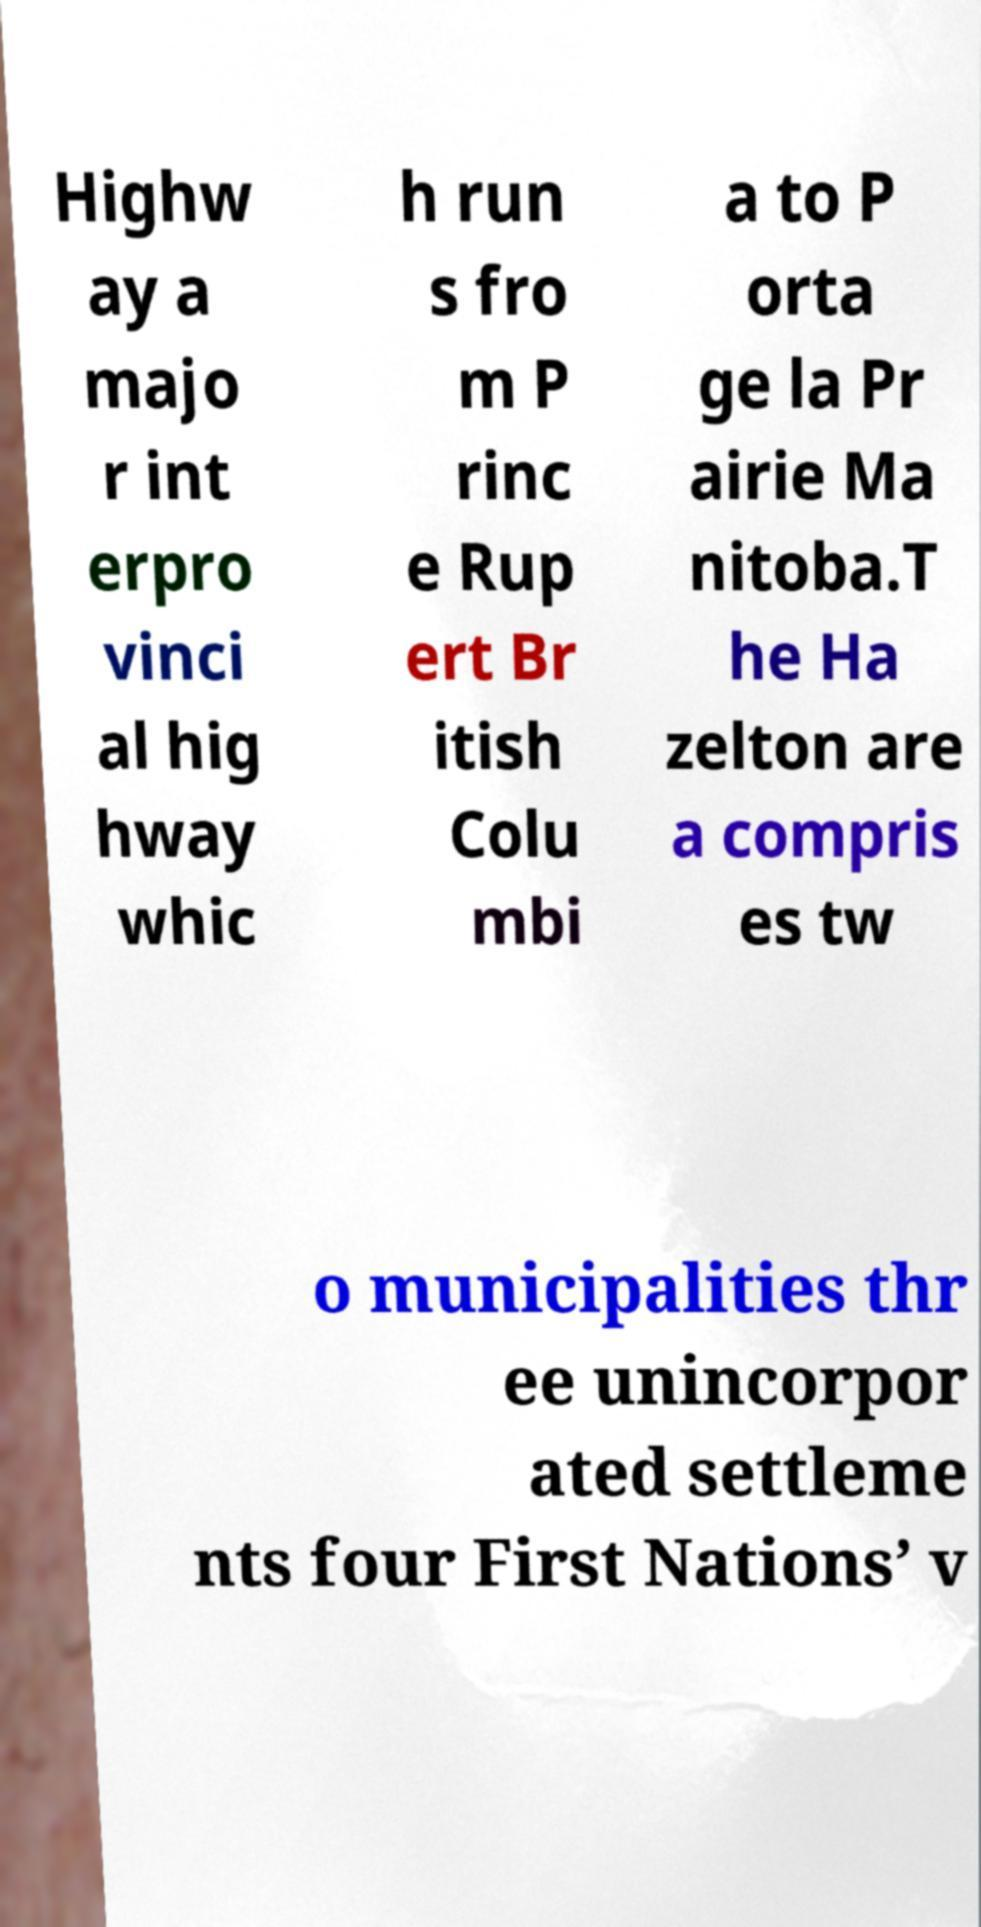I need the written content from this picture converted into text. Can you do that? Highw ay a majo r int erpro vinci al hig hway whic h run s fro m P rinc e Rup ert Br itish Colu mbi a to P orta ge la Pr airie Ma nitoba.T he Ha zelton are a compris es tw o municipalities thr ee unincorpor ated settleme nts four First Nations’ v 